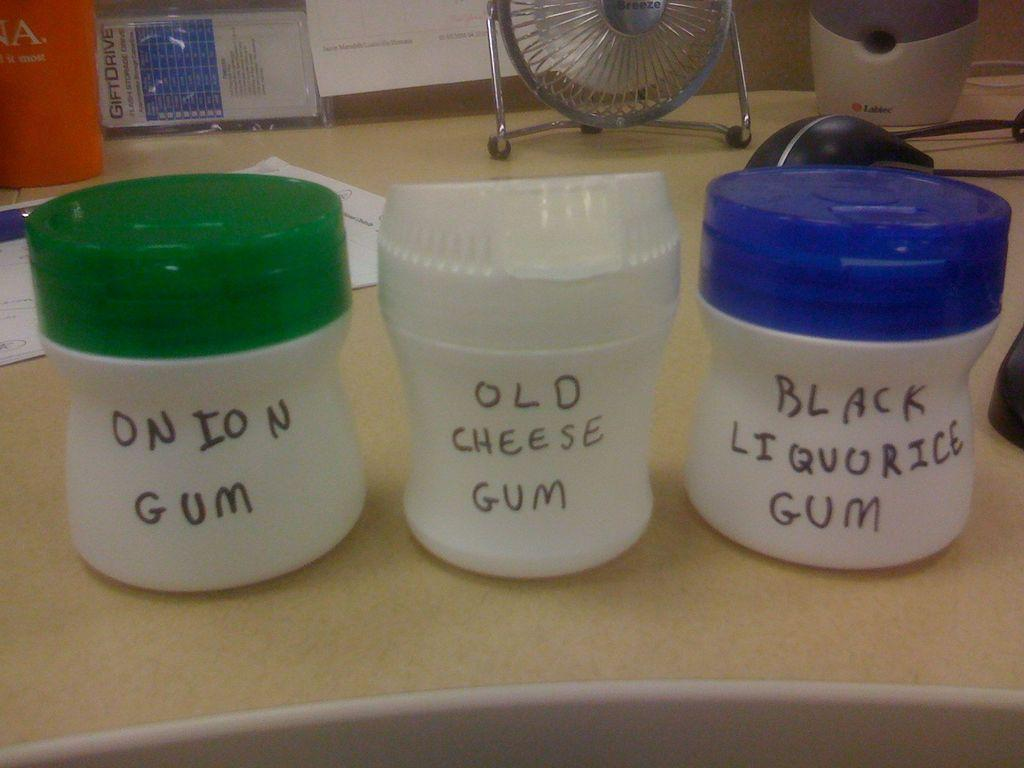<image>
Provide a brief description of the given image. Three jars with the names onion gum, old cheese gum and black liquorice sit on a counter 